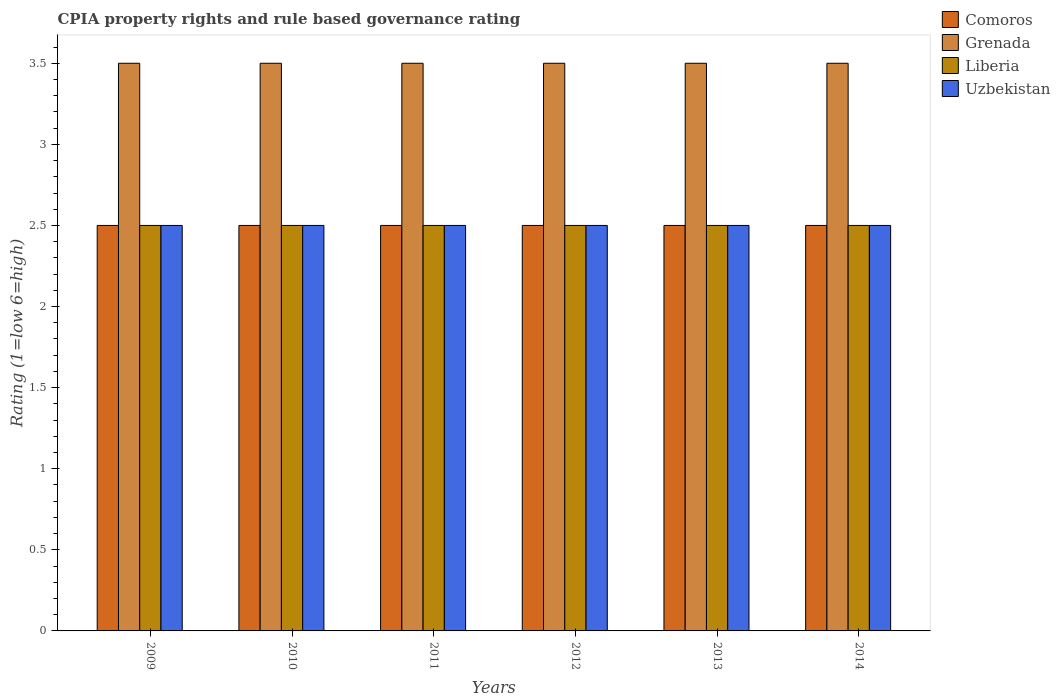How many different coloured bars are there?
Provide a short and direct response. 4. How many groups of bars are there?
Offer a terse response. 6. Are the number of bars per tick equal to the number of legend labels?
Give a very brief answer. Yes. How many bars are there on the 1st tick from the left?
Your response must be concise. 4. How many bars are there on the 6th tick from the right?
Your response must be concise. 4. In how many cases, is the number of bars for a given year not equal to the number of legend labels?
Keep it short and to the point. 0. Across all years, what is the maximum CPIA rating in Liberia?
Your response must be concise. 2.5. Across all years, what is the minimum CPIA rating in Grenada?
Make the answer very short. 3.5. In which year was the CPIA rating in Comoros minimum?
Make the answer very short. 2009. What is the difference between the CPIA rating in Liberia in 2009 and that in 2011?
Your answer should be very brief. 0. What is the difference between the CPIA rating in Comoros in 2012 and the CPIA rating in Uzbekistan in 2013?
Ensure brevity in your answer.  0. What is the average CPIA rating in Uzbekistan per year?
Keep it short and to the point. 2.5. In the year 2014, what is the difference between the CPIA rating in Comoros and CPIA rating in Liberia?
Make the answer very short. 0. What is the ratio of the CPIA rating in Uzbekistan in 2010 to that in 2014?
Your answer should be very brief. 1. What is the difference between the highest and the second highest CPIA rating in Uzbekistan?
Ensure brevity in your answer.  0. What is the difference between the highest and the lowest CPIA rating in Comoros?
Offer a very short reply. 0. Is the sum of the CPIA rating in Liberia in 2010 and 2014 greater than the maximum CPIA rating in Uzbekistan across all years?
Make the answer very short. Yes. Is it the case that in every year, the sum of the CPIA rating in Comoros and CPIA rating in Uzbekistan is greater than the sum of CPIA rating in Grenada and CPIA rating in Liberia?
Offer a terse response. No. What does the 2nd bar from the left in 2011 represents?
Your response must be concise. Grenada. What does the 2nd bar from the right in 2009 represents?
Your answer should be compact. Liberia. Is it the case that in every year, the sum of the CPIA rating in Uzbekistan and CPIA rating in Comoros is greater than the CPIA rating in Liberia?
Your answer should be compact. Yes. What is the difference between two consecutive major ticks on the Y-axis?
Offer a terse response. 0.5. Does the graph contain grids?
Your response must be concise. No. How are the legend labels stacked?
Keep it short and to the point. Vertical. What is the title of the graph?
Make the answer very short. CPIA property rights and rule based governance rating. Does "Kiribati" appear as one of the legend labels in the graph?
Your answer should be compact. No. What is the label or title of the Y-axis?
Your answer should be compact. Rating (1=low 6=high). What is the Rating (1=low 6=high) of Comoros in 2009?
Give a very brief answer. 2.5. What is the Rating (1=low 6=high) of Grenada in 2009?
Ensure brevity in your answer.  3.5. What is the Rating (1=low 6=high) in Uzbekistan in 2009?
Ensure brevity in your answer.  2.5. What is the Rating (1=low 6=high) of Comoros in 2010?
Provide a succinct answer. 2.5. What is the Rating (1=low 6=high) in Grenada in 2010?
Your answer should be compact. 3.5. What is the Rating (1=low 6=high) of Liberia in 2010?
Give a very brief answer. 2.5. What is the Rating (1=low 6=high) of Grenada in 2011?
Keep it short and to the point. 3.5. What is the Rating (1=low 6=high) of Comoros in 2012?
Offer a terse response. 2.5. What is the Rating (1=low 6=high) of Grenada in 2012?
Your response must be concise. 3.5. What is the Rating (1=low 6=high) of Grenada in 2013?
Offer a very short reply. 3.5. What is the Rating (1=low 6=high) of Liberia in 2013?
Offer a terse response. 2.5. What is the Rating (1=low 6=high) in Uzbekistan in 2014?
Your answer should be very brief. 2.5. Across all years, what is the maximum Rating (1=low 6=high) in Grenada?
Offer a very short reply. 3.5. Across all years, what is the maximum Rating (1=low 6=high) in Liberia?
Offer a very short reply. 2.5. Across all years, what is the minimum Rating (1=low 6=high) in Uzbekistan?
Ensure brevity in your answer.  2.5. What is the difference between the Rating (1=low 6=high) in Grenada in 2009 and that in 2010?
Your answer should be compact. 0. What is the difference between the Rating (1=low 6=high) of Liberia in 2009 and that in 2010?
Your answer should be compact. 0. What is the difference between the Rating (1=low 6=high) in Comoros in 2009 and that in 2011?
Give a very brief answer. 0. What is the difference between the Rating (1=low 6=high) of Grenada in 2009 and that in 2012?
Give a very brief answer. 0. What is the difference between the Rating (1=low 6=high) of Liberia in 2009 and that in 2012?
Ensure brevity in your answer.  0. What is the difference between the Rating (1=low 6=high) of Uzbekistan in 2009 and that in 2012?
Keep it short and to the point. 0. What is the difference between the Rating (1=low 6=high) of Grenada in 2009 and that in 2013?
Give a very brief answer. 0. What is the difference between the Rating (1=low 6=high) in Uzbekistan in 2009 and that in 2013?
Offer a very short reply. 0. What is the difference between the Rating (1=low 6=high) in Comoros in 2009 and that in 2014?
Your answer should be very brief. 0. What is the difference between the Rating (1=low 6=high) of Grenada in 2009 and that in 2014?
Provide a succinct answer. 0. What is the difference between the Rating (1=low 6=high) of Uzbekistan in 2010 and that in 2012?
Keep it short and to the point. 0. What is the difference between the Rating (1=low 6=high) in Comoros in 2010 and that in 2013?
Your response must be concise. 0. What is the difference between the Rating (1=low 6=high) of Grenada in 2010 and that in 2013?
Offer a terse response. 0. What is the difference between the Rating (1=low 6=high) of Comoros in 2010 and that in 2014?
Provide a short and direct response. 0. What is the difference between the Rating (1=low 6=high) in Grenada in 2010 and that in 2014?
Your answer should be very brief. 0. What is the difference between the Rating (1=low 6=high) in Liberia in 2010 and that in 2014?
Provide a short and direct response. 0. What is the difference between the Rating (1=low 6=high) of Uzbekistan in 2010 and that in 2014?
Keep it short and to the point. 0. What is the difference between the Rating (1=low 6=high) of Comoros in 2011 and that in 2012?
Make the answer very short. 0. What is the difference between the Rating (1=low 6=high) in Grenada in 2011 and that in 2012?
Your response must be concise. 0. What is the difference between the Rating (1=low 6=high) of Comoros in 2011 and that in 2013?
Provide a succinct answer. 0. What is the difference between the Rating (1=low 6=high) of Uzbekistan in 2011 and that in 2014?
Provide a short and direct response. 0. What is the difference between the Rating (1=low 6=high) of Grenada in 2012 and that in 2013?
Keep it short and to the point. 0. What is the difference between the Rating (1=low 6=high) of Liberia in 2012 and that in 2013?
Keep it short and to the point. 0. What is the difference between the Rating (1=low 6=high) in Uzbekistan in 2012 and that in 2013?
Offer a terse response. 0. What is the difference between the Rating (1=low 6=high) in Comoros in 2012 and that in 2014?
Your answer should be very brief. 0. What is the difference between the Rating (1=low 6=high) of Liberia in 2012 and that in 2014?
Make the answer very short. 0. What is the difference between the Rating (1=low 6=high) in Uzbekistan in 2013 and that in 2014?
Offer a very short reply. 0. What is the difference between the Rating (1=low 6=high) in Comoros in 2009 and the Rating (1=low 6=high) in Uzbekistan in 2010?
Your answer should be very brief. 0. What is the difference between the Rating (1=low 6=high) of Grenada in 2009 and the Rating (1=low 6=high) of Liberia in 2010?
Make the answer very short. 1. What is the difference between the Rating (1=low 6=high) in Grenada in 2009 and the Rating (1=low 6=high) in Uzbekistan in 2010?
Make the answer very short. 1. What is the difference between the Rating (1=low 6=high) of Liberia in 2009 and the Rating (1=low 6=high) of Uzbekistan in 2010?
Provide a short and direct response. 0. What is the difference between the Rating (1=low 6=high) in Comoros in 2009 and the Rating (1=low 6=high) in Grenada in 2011?
Your answer should be compact. -1. What is the difference between the Rating (1=low 6=high) of Comoros in 2009 and the Rating (1=low 6=high) of Liberia in 2011?
Make the answer very short. 0. What is the difference between the Rating (1=low 6=high) of Grenada in 2009 and the Rating (1=low 6=high) of Uzbekistan in 2011?
Offer a very short reply. 1. What is the difference between the Rating (1=low 6=high) of Comoros in 2009 and the Rating (1=low 6=high) of Uzbekistan in 2012?
Offer a terse response. 0. What is the difference between the Rating (1=low 6=high) of Liberia in 2009 and the Rating (1=low 6=high) of Uzbekistan in 2012?
Provide a succinct answer. 0. What is the difference between the Rating (1=low 6=high) of Comoros in 2009 and the Rating (1=low 6=high) of Liberia in 2013?
Provide a short and direct response. 0. What is the difference between the Rating (1=low 6=high) in Grenada in 2009 and the Rating (1=low 6=high) in Uzbekistan in 2013?
Give a very brief answer. 1. What is the difference between the Rating (1=low 6=high) in Comoros in 2009 and the Rating (1=low 6=high) in Liberia in 2014?
Ensure brevity in your answer.  0. What is the difference between the Rating (1=low 6=high) of Comoros in 2009 and the Rating (1=low 6=high) of Uzbekistan in 2014?
Your answer should be very brief. 0. What is the difference between the Rating (1=low 6=high) of Grenada in 2009 and the Rating (1=low 6=high) of Liberia in 2014?
Make the answer very short. 1. What is the difference between the Rating (1=low 6=high) in Liberia in 2009 and the Rating (1=low 6=high) in Uzbekistan in 2014?
Your answer should be very brief. 0. What is the difference between the Rating (1=low 6=high) of Comoros in 2010 and the Rating (1=low 6=high) of Liberia in 2011?
Make the answer very short. 0. What is the difference between the Rating (1=low 6=high) of Comoros in 2010 and the Rating (1=low 6=high) of Uzbekistan in 2011?
Keep it short and to the point. 0. What is the difference between the Rating (1=low 6=high) in Comoros in 2010 and the Rating (1=low 6=high) in Grenada in 2012?
Provide a short and direct response. -1. What is the difference between the Rating (1=low 6=high) in Comoros in 2010 and the Rating (1=low 6=high) in Liberia in 2012?
Your answer should be very brief. 0. What is the difference between the Rating (1=low 6=high) of Grenada in 2010 and the Rating (1=low 6=high) of Liberia in 2012?
Offer a very short reply. 1. What is the difference between the Rating (1=low 6=high) in Comoros in 2010 and the Rating (1=low 6=high) in Liberia in 2013?
Provide a short and direct response. 0. What is the difference between the Rating (1=low 6=high) of Grenada in 2010 and the Rating (1=low 6=high) of Liberia in 2013?
Provide a short and direct response. 1. What is the difference between the Rating (1=low 6=high) in Comoros in 2010 and the Rating (1=low 6=high) in Grenada in 2014?
Make the answer very short. -1. What is the difference between the Rating (1=low 6=high) in Comoros in 2010 and the Rating (1=low 6=high) in Liberia in 2014?
Offer a terse response. 0. What is the difference between the Rating (1=low 6=high) in Comoros in 2010 and the Rating (1=low 6=high) in Uzbekistan in 2014?
Your answer should be compact. 0. What is the difference between the Rating (1=low 6=high) in Comoros in 2011 and the Rating (1=low 6=high) in Grenada in 2012?
Offer a very short reply. -1. What is the difference between the Rating (1=low 6=high) in Grenada in 2011 and the Rating (1=low 6=high) in Liberia in 2012?
Offer a very short reply. 1. What is the difference between the Rating (1=low 6=high) of Liberia in 2011 and the Rating (1=low 6=high) of Uzbekistan in 2012?
Offer a terse response. 0. What is the difference between the Rating (1=low 6=high) of Comoros in 2011 and the Rating (1=low 6=high) of Liberia in 2013?
Your answer should be very brief. 0. What is the difference between the Rating (1=low 6=high) in Grenada in 2011 and the Rating (1=low 6=high) in Liberia in 2013?
Provide a succinct answer. 1. What is the difference between the Rating (1=low 6=high) in Grenada in 2011 and the Rating (1=low 6=high) in Uzbekistan in 2013?
Your response must be concise. 1. What is the difference between the Rating (1=low 6=high) in Comoros in 2011 and the Rating (1=low 6=high) in Liberia in 2014?
Make the answer very short. 0. What is the difference between the Rating (1=low 6=high) of Grenada in 2011 and the Rating (1=low 6=high) of Uzbekistan in 2014?
Offer a very short reply. 1. What is the difference between the Rating (1=low 6=high) in Comoros in 2012 and the Rating (1=low 6=high) in Grenada in 2013?
Offer a terse response. -1. What is the difference between the Rating (1=low 6=high) in Comoros in 2012 and the Rating (1=low 6=high) in Liberia in 2013?
Give a very brief answer. 0. What is the difference between the Rating (1=low 6=high) of Grenada in 2012 and the Rating (1=low 6=high) of Uzbekistan in 2013?
Your response must be concise. 1. What is the difference between the Rating (1=low 6=high) of Liberia in 2012 and the Rating (1=low 6=high) of Uzbekistan in 2013?
Provide a succinct answer. 0. What is the difference between the Rating (1=low 6=high) of Grenada in 2012 and the Rating (1=low 6=high) of Liberia in 2014?
Keep it short and to the point. 1. What is the difference between the Rating (1=low 6=high) in Grenada in 2012 and the Rating (1=low 6=high) in Uzbekistan in 2014?
Provide a succinct answer. 1. What is the difference between the Rating (1=low 6=high) in Liberia in 2012 and the Rating (1=low 6=high) in Uzbekistan in 2014?
Provide a succinct answer. 0. What is the difference between the Rating (1=low 6=high) of Comoros in 2013 and the Rating (1=low 6=high) of Grenada in 2014?
Your answer should be compact. -1. What is the difference between the Rating (1=low 6=high) of Comoros in 2013 and the Rating (1=low 6=high) of Uzbekistan in 2014?
Provide a succinct answer. 0. What is the difference between the Rating (1=low 6=high) in Grenada in 2013 and the Rating (1=low 6=high) in Liberia in 2014?
Your answer should be very brief. 1. What is the average Rating (1=low 6=high) in Comoros per year?
Offer a very short reply. 2.5. In the year 2009, what is the difference between the Rating (1=low 6=high) of Comoros and Rating (1=low 6=high) of Uzbekistan?
Your response must be concise. 0. In the year 2009, what is the difference between the Rating (1=low 6=high) in Grenada and Rating (1=low 6=high) in Liberia?
Your answer should be compact. 1. In the year 2010, what is the difference between the Rating (1=low 6=high) of Comoros and Rating (1=low 6=high) of Grenada?
Provide a succinct answer. -1. In the year 2010, what is the difference between the Rating (1=low 6=high) in Comoros and Rating (1=low 6=high) in Liberia?
Your response must be concise. 0. In the year 2010, what is the difference between the Rating (1=low 6=high) in Comoros and Rating (1=low 6=high) in Uzbekistan?
Your answer should be compact. 0. In the year 2010, what is the difference between the Rating (1=low 6=high) in Grenada and Rating (1=low 6=high) in Liberia?
Offer a very short reply. 1. In the year 2011, what is the difference between the Rating (1=low 6=high) of Comoros and Rating (1=low 6=high) of Grenada?
Offer a very short reply. -1. In the year 2011, what is the difference between the Rating (1=low 6=high) of Comoros and Rating (1=low 6=high) of Liberia?
Make the answer very short. 0. In the year 2011, what is the difference between the Rating (1=low 6=high) in Grenada and Rating (1=low 6=high) in Uzbekistan?
Give a very brief answer. 1. In the year 2011, what is the difference between the Rating (1=low 6=high) of Liberia and Rating (1=low 6=high) of Uzbekistan?
Your answer should be very brief. 0. In the year 2012, what is the difference between the Rating (1=low 6=high) in Comoros and Rating (1=low 6=high) in Grenada?
Keep it short and to the point. -1. In the year 2012, what is the difference between the Rating (1=low 6=high) of Comoros and Rating (1=low 6=high) of Liberia?
Give a very brief answer. 0. In the year 2012, what is the difference between the Rating (1=low 6=high) in Comoros and Rating (1=low 6=high) in Uzbekistan?
Your response must be concise. 0. In the year 2012, what is the difference between the Rating (1=low 6=high) of Grenada and Rating (1=low 6=high) of Uzbekistan?
Ensure brevity in your answer.  1. In the year 2013, what is the difference between the Rating (1=low 6=high) in Grenada and Rating (1=low 6=high) in Liberia?
Make the answer very short. 1. In the year 2013, what is the difference between the Rating (1=low 6=high) in Grenada and Rating (1=low 6=high) in Uzbekistan?
Make the answer very short. 1. In the year 2013, what is the difference between the Rating (1=low 6=high) of Liberia and Rating (1=low 6=high) of Uzbekistan?
Your answer should be compact. 0. In the year 2014, what is the difference between the Rating (1=low 6=high) of Comoros and Rating (1=low 6=high) of Grenada?
Provide a short and direct response. -1. In the year 2014, what is the difference between the Rating (1=low 6=high) in Comoros and Rating (1=low 6=high) in Uzbekistan?
Offer a very short reply. 0. In the year 2014, what is the difference between the Rating (1=low 6=high) of Grenada and Rating (1=low 6=high) of Uzbekistan?
Offer a very short reply. 1. In the year 2014, what is the difference between the Rating (1=low 6=high) of Liberia and Rating (1=low 6=high) of Uzbekistan?
Your answer should be compact. 0. What is the ratio of the Rating (1=low 6=high) of Uzbekistan in 2009 to that in 2010?
Provide a short and direct response. 1. What is the ratio of the Rating (1=low 6=high) of Comoros in 2009 to that in 2011?
Keep it short and to the point. 1. What is the ratio of the Rating (1=low 6=high) in Liberia in 2009 to that in 2011?
Provide a short and direct response. 1. What is the ratio of the Rating (1=low 6=high) in Uzbekistan in 2009 to that in 2011?
Your answer should be very brief. 1. What is the ratio of the Rating (1=low 6=high) in Comoros in 2009 to that in 2012?
Your response must be concise. 1. What is the ratio of the Rating (1=low 6=high) of Grenada in 2009 to that in 2012?
Provide a short and direct response. 1. What is the ratio of the Rating (1=low 6=high) of Comoros in 2009 to that in 2013?
Offer a very short reply. 1. What is the ratio of the Rating (1=low 6=high) of Grenada in 2009 to that in 2013?
Provide a succinct answer. 1. What is the ratio of the Rating (1=low 6=high) of Liberia in 2009 to that in 2013?
Your answer should be very brief. 1. What is the ratio of the Rating (1=low 6=high) in Grenada in 2009 to that in 2014?
Your answer should be compact. 1. What is the ratio of the Rating (1=low 6=high) in Uzbekistan in 2009 to that in 2014?
Make the answer very short. 1. What is the ratio of the Rating (1=low 6=high) in Comoros in 2010 to that in 2011?
Give a very brief answer. 1. What is the ratio of the Rating (1=low 6=high) in Grenada in 2010 to that in 2011?
Offer a terse response. 1. What is the ratio of the Rating (1=low 6=high) of Liberia in 2010 to that in 2011?
Your response must be concise. 1. What is the ratio of the Rating (1=low 6=high) in Comoros in 2010 to that in 2012?
Offer a very short reply. 1. What is the ratio of the Rating (1=low 6=high) in Grenada in 2010 to that in 2013?
Offer a terse response. 1. What is the ratio of the Rating (1=low 6=high) of Liberia in 2010 to that in 2013?
Offer a very short reply. 1. What is the ratio of the Rating (1=low 6=high) of Comoros in 2010 to that in 2014?
Your response must be concise. 1. What is the ratio of the Rating (1=low 6=high) in Grenada in 2010 to that in 2014?
Your response must be concise. 1. What is the ratio of the Rating (1=low 6=high) in Liberia in 2010 to that in 2014?
Your answer should be compact. 1. What is the ratio of the Rating (1=low 6=high) of Uzbekistan in 2011 to that in 2012?
Provide a succinct answer. 1. What is the ratio of the Rating (1=low 6=high) in Grenada in 2011 to that in 2013?
Your response must be concise. 1. What is the ratio of the Rating (1=low 6=high) of Liberia in 2011 to that in 2013?
Your response must be concise. 1. What is the ratio of the Rating (1=low 6=high) of Uzbekistan in 2011 to that in 2013?
Your response must be concise. 1. What is the ratio of the Rating (1=low 6=high) in Uzbekistan in 2011 to that in 2014?
Your answer should be very brief. 1. What is the ratio of the Rating (1=low 6=high) of Comoros in 2012 to that in 2013?
Offer a terse response. 1. What is the ratio of the Rating (1=low 6=high) of Grenada in 2012 to that in 2013?
Offer a very short reply. 1. What is the ratio of the Rating (1=low 6=high) in Uzbekistan in 2012 to that in 2013?
Offer a very short reply. 1. What is the ratio of the Rating (1=low 6=high) in Comoros in 2013 to that in 2014?
Ensure brevity in your answer.  1. What is the ratio of the Rating (1=low 6=high) of Grenada in 2013 to that in 2014?
Offer a terse response. 1. What is the ratio of the Rating (1=low 6=high) in Liberia in 2013 to that in 2014?
Offer a terse response. 1. What is the difference between the highest and the second highest Rating (1=low 6=high) of Grenada?
Offer a terse response. 0. What is the difference between the highest and the lowest Rating (1=low 6=high) in Liberia?
Provide a succinct answer. 0. What is the difference between the highest and the lowest Rating (1=low 6=high) of Uzbekistan?
Keep it short and to the point. 0. 